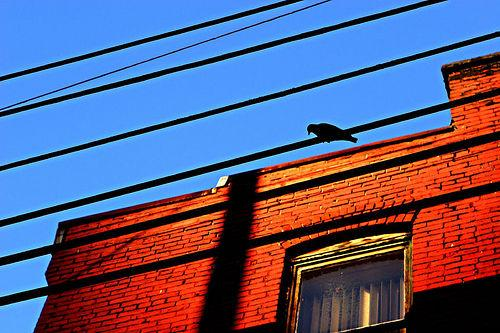What color is the dominant feature in the picture, and what is it doing? The black bird is the dominant feature and it is sitting on a power line. Briefly describe the key subject in the image and its surroundings. A black bird sits on a power line, surrounded by red brick buildings and a clear blue sky. Mention the type of building and its main feature present in the image. The building is made of red bricks and has a window on its side. What material is the building made of, and what is one notable feature about it? The building is made of red bricks, and it has a window on the side. In one sentence, describe the weather and a prominent element in the image. It is a clear and bright blue sky with no clouds and a black bird on a power line. What is the primary action happening in the scene, and what object is involved? The primary action is a black bird perching on a wire. Point out the main structure in the image and what it is made up of. The main structure is a building, and it is made up of red bricks. 